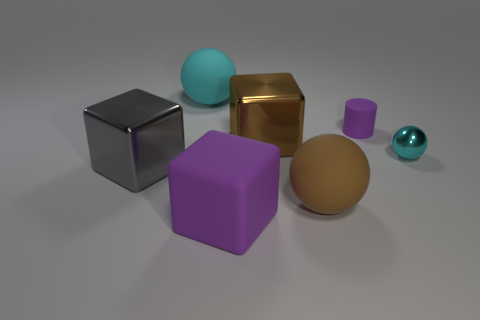Add 1 cylinders. How many objects exist? 8 Subtract all blocks. How many objects are left? 4 Add 3 tiny rubber objects. How many tiny rubber objects are left? 4 Add 4 big gray shiny things. How many big gray shiny things exist? 5 Subtract 0 gray cylinders. How many objects are left? 7 Subtract all large blue matte cubes. Subtract all large gray metal cubes. How many objects are left? 6 